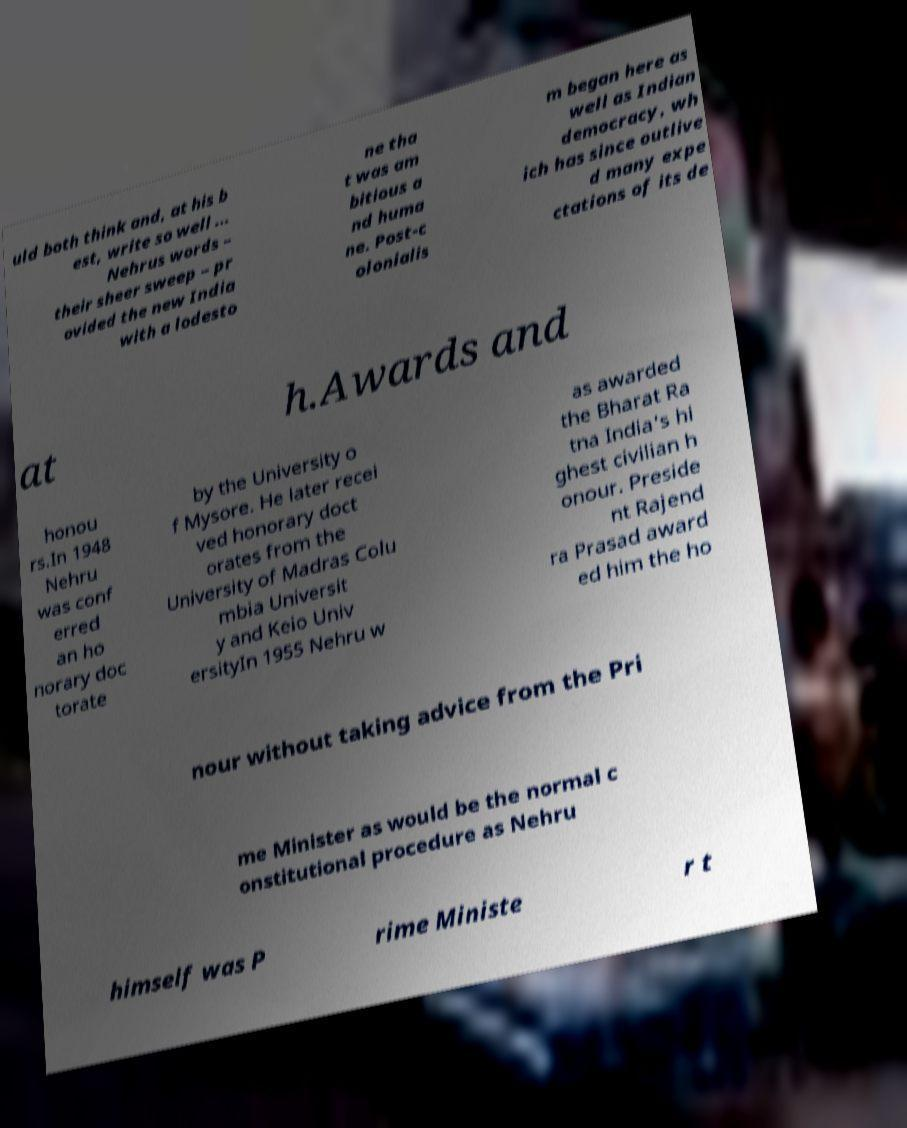For documentation purposes, I need the text within this image transcribed. Could you provide that? uld both think and, at his b est, write so well ... Nehrus words – their sheer sweep – pr ovided the new India with a lodesto ne tha t was am bitious a nd huma ne. Post-c olonialis m began here as well as Indian democracy, wh ich has since outlive d many expe ctations of its de at h.Awards and honou rs.In 1948 Nehru was conf erred an ho norary doc torate by the University o f Mysore. He later recei ved honorary doct orates from the University of Madras Colu mbia Universit y and Keio Univ ersityIn 1955 Nehru w as awarded the Bharat Ra tna India's hi ghest civilian h onour. Preside nt Rajend ra Prasad award ed him the ho nour without taking advice from the Pri me Minister as would be the normal c onstitutional procedure as Nehru himself was P rime Ministe r t 